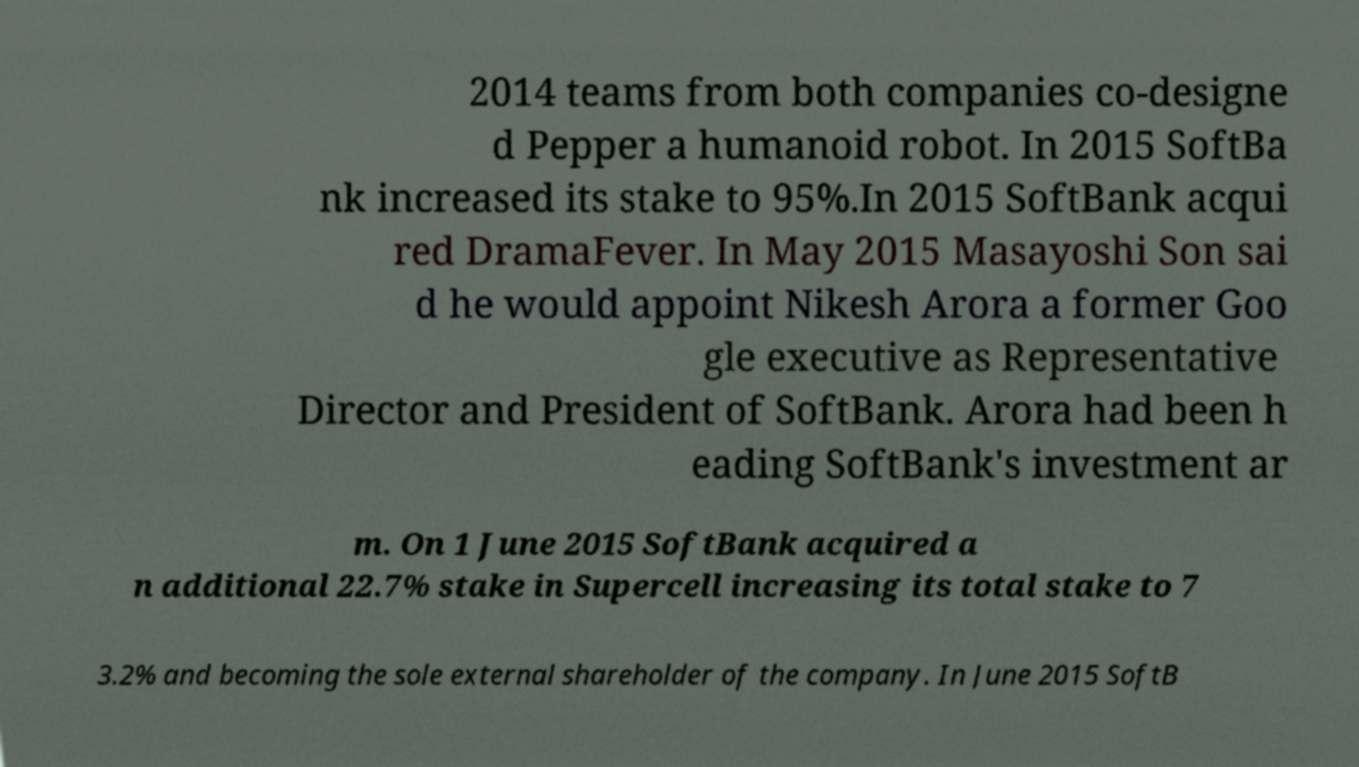For documentation purposes, I need the text within this image transcribed. Could you provide that? 2014 teams from both companies co-designe d Pepper a humanoid robot. In 2015 SoftBa nk increased its stake to 95%.In 2015 SoftBank acqui red DramaFever. In May 2015 Masayoshi Son sai d he would appoint Nikesh Arora a former Goo gle executive as Representative Director and President of SoftBank. Arora had been h eading SoftBank's investment ar m. On 1 June 2015 SoftBank acquired a n additional 22.7% stake in Supercell increasing its total stake to 7 3.2% and becoming the sole external shareholder of the company. In June 2015 SoftB 